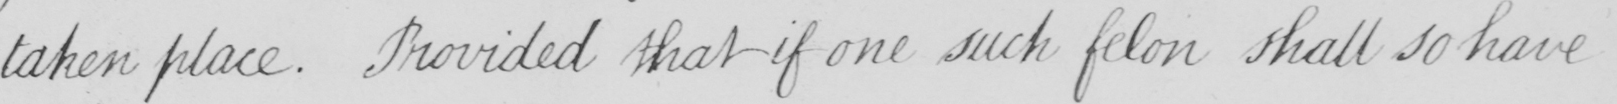Can you tell me what this handwritten text says? taken place . Provided that if one such felon shall so have 